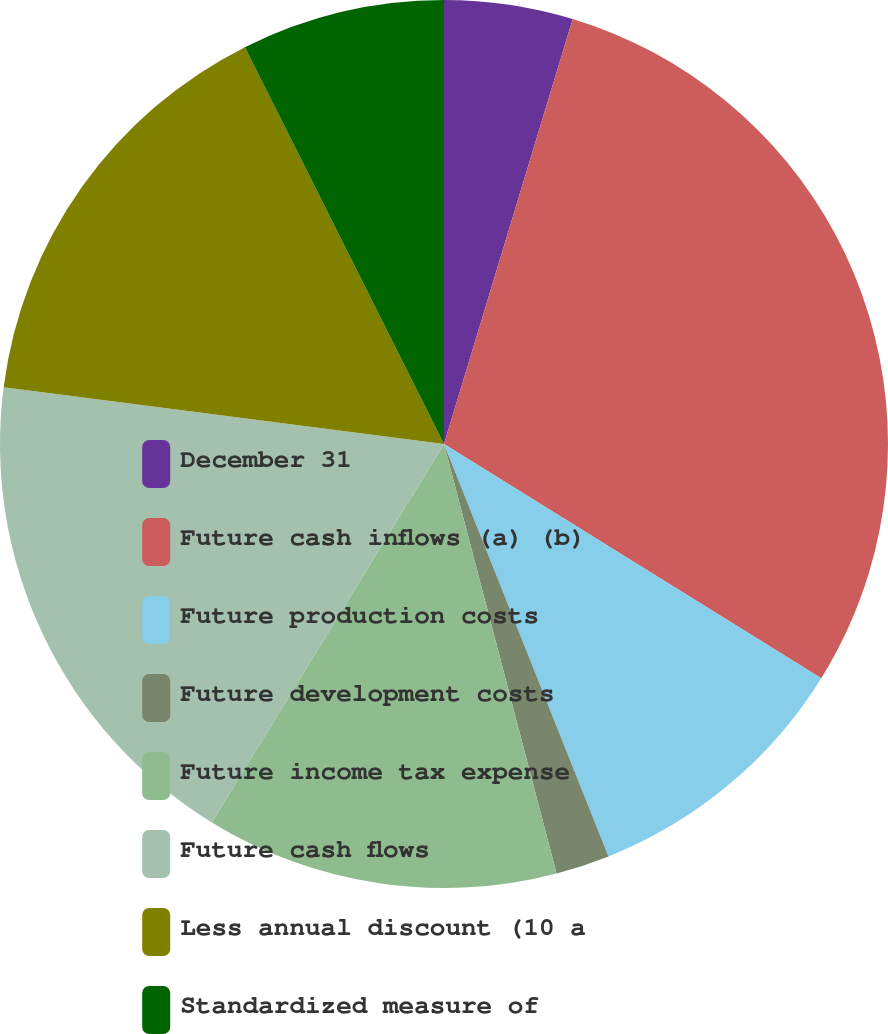Convert chart to OTSL. <chart><loc_0><loc_0><loc_500><loc_500><pie_chart><fcel>December 31<fcel>Future cash inflows (a) (b)<fcel>Future production costs<fcel>Future development costs<fcel>Future income tax expense<fcel>Future cash flows<fcel>Less annual discount (10 a<fcel>Standardized measure of<nl><fcel>4.68%<fcel>29.16%<fcel>10.12%<fcel>1.96%<fcel>12.84%<fcel>18.28%<fcel>15.56%<fcel>7.4%<nl></chart> 